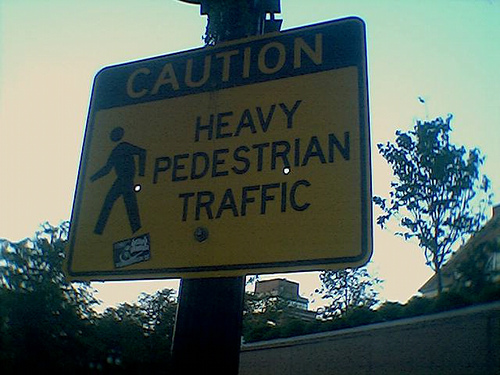What does the sign in the image indicate? The sign indicates 'CAUTION HEAVY PEDESTRIAN TRAFFIC', which means it is warning drivers and cyclists to expect a high volume of pedestrians in the area and to proceed with caution. 